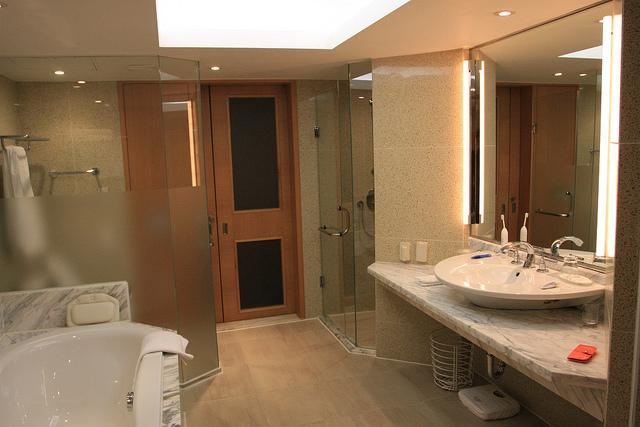What color is the little purse on the marble countertop next to the big raised sink? orange 